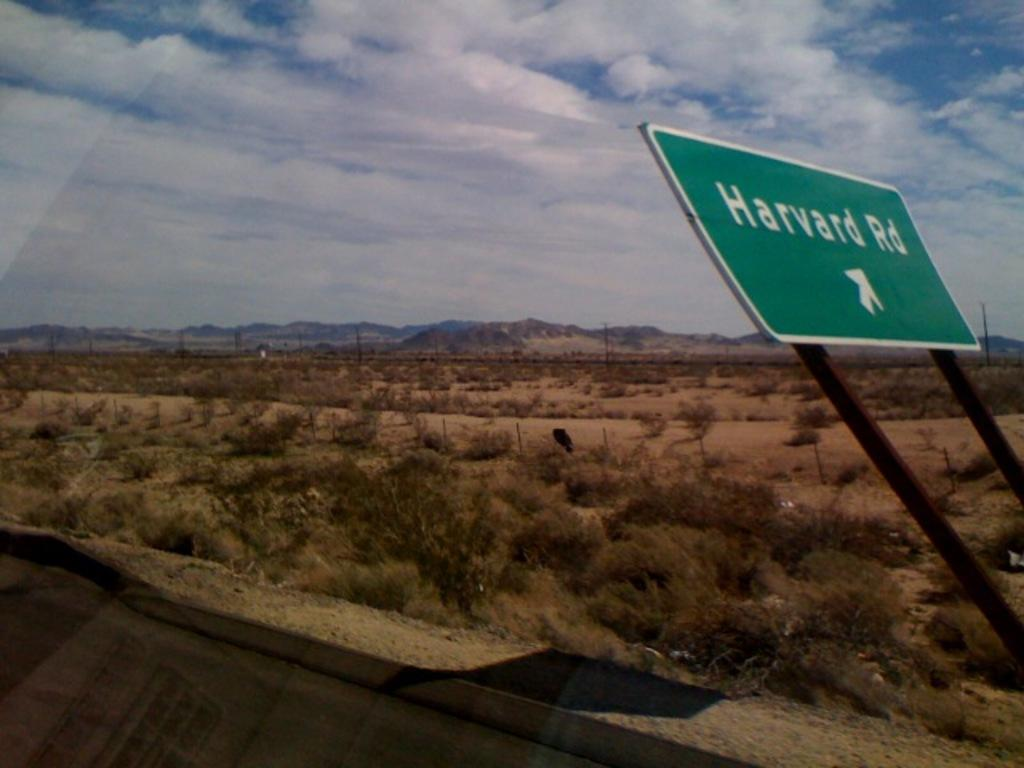<image>
Describe the image concisely. An almost knocked down sign showing that Harvard Rd. is to the right. 